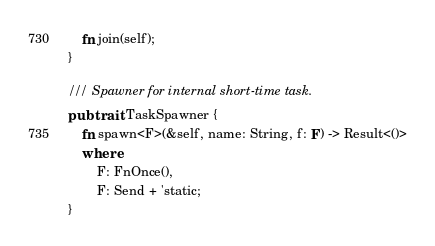Convert code to text. <code><loc_0><loc_0><loc_500><loc_500><_Rust_>    fn join(self);
}

/// Spawner for internal short-time task.
pub trait TaskSpawner {
    fn spawn<F>(&self, name: String, f: F) -> Result<()>
    where
        F: FnOnce(),
        F: Send + 'static;
}
</code> 